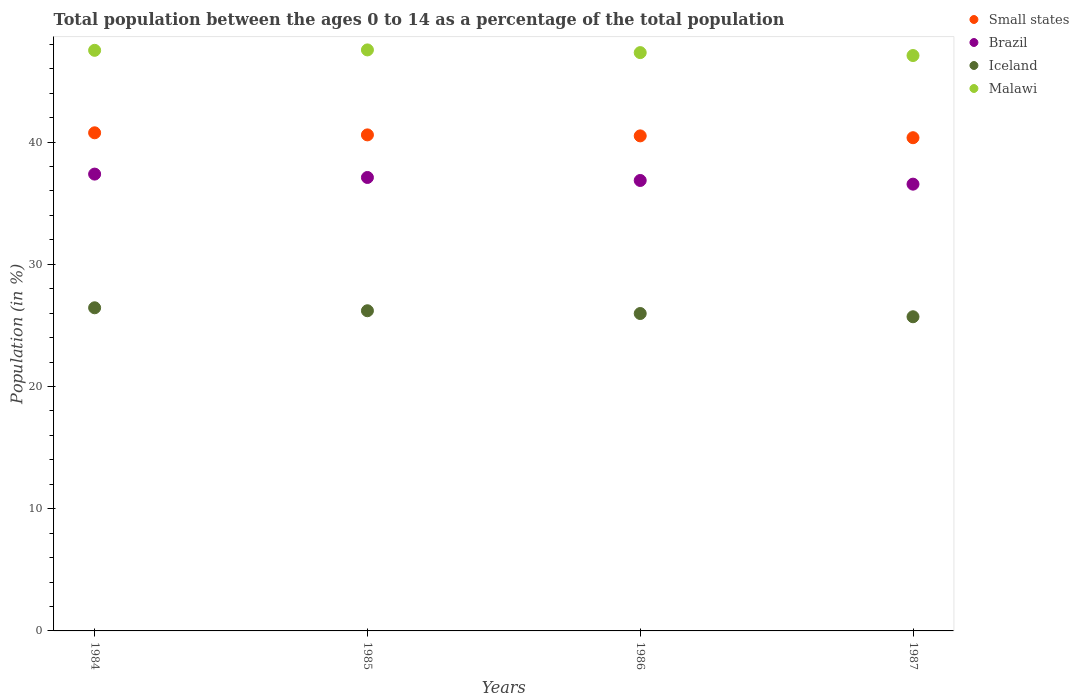How many different coloured dotlines are there?
Your answer should be very brief. 4. What is the percentage of the population ages 0 to 14 in Iceland in 1986?
Provide a short and direct response. 25.97. Across all years, what is the maximum percentage of the population ages 0 to 14 in Small states?
Provide a short and direct response. 40.75. Across all years, what is the minimum percentage of the population ages 0 to 14 in Iceland?
Ensure brevity in your answer.  25.7. In which year was the percentage of the population ages 0 to 14 in Iceland maximum?
Make the answer very short. 1984. What is the total percentage of the population ages 0 to 14 in Small states in the graph?
Give a very brief answer. 162.19. What is the difference between the percentage of the population ages 0 to 14 in Malawi in 1984 and that in 1986?
Your answer should be very brief. 0.19. What is the difference between the percentage of the population ages 0 to 14 in Brazil in 1985 and the percentage of the population ages 0 to 14 in Iceland in 1984?
Make the answer very short. 10.66. What is the average percentage of the population ages 0 to 14 in Small states per year?
Offer a very short reply. 40.55. In the year 1984, what is the difference between the percentage of the population ages 0 to 14 in Small states and percentage of the population ages 0 to 14 in Iceland?
Your response must be concise. 14.32. In how many years, is the percentage of the population ages 0 to 14 in Iceland greater than 44?
Make the answer very short. 0. What is the ratio of the percentage of the population ages 0 to 14 in Brazil in 1984 to that in 1985?
Ensure brevity in your answer.  1.01. Is the percentage of the population ages 0 to 14 in Small states in 1986 less than that in 1987?
Offer a very short reply. No. Is the difference between the percentage of the population ages 0 to 14 in Small states in 1984 and 1985 greater than the difference between the percentage of the population ages 0 to 14 in Iceland in 1984 and 1985?
Give a very brief answer. No. What is the difference between the highest and the second highest percentage of the population ages 0 to 14 in Malawi?
Provide a short and direct response. 0.03. What is the difference between the highest and the lowest percentage of the population ages 0 to 14 in Malawi?
Provide a short and direct response. 0.46. Is it the case that in every year, the sum of the percentage of the population ages 0 to 14 in Iceland and percentage of the population ages 0 to 14 in Brazil  is greater than the sum of percentage of the population ages 0 to 14 in Small states and percentage of the population ages 0 to 14 in Malawi?
Give a very brief answer. Yes. Is it the case that in every year, the sum of the percentage of the population ages 0 to 14 in Small states and percentage of the population ages 0 to 14 in Iceland  is greater than the percentage of the population ages 0 to 14 in Malawi?
Give a very brief answer. Yes. Is the percentage of the population ages 0 to 14 in Small states strictly greater than the percentage of the population ages 0 to 14 in Brazil over the years?
Give a very brief answer. Yes. How many years are there in the graph?
Your answer should be very brief. 4. Does the graph contain grids?
Give a very brief answer. No. Where does the legend appear in the graph?
Your response must be concise. Top right. How many legend labels are there?
Provide a succinct answer. 4. How are the legend labels stacked?
Offer a terse response. Vertical. What is the title of the graph?
Offer a very short reply. Total population between the ages 0 to 14 as a percentage of the total population. What is the label or title of the Y-axis?
Offer a very short reply. Population (in %). What is the Population (in %) in Small states in 1984?
Make the answer very short. 40.75. What is the Population (in %) in Brazil in 1984?
Provide a short and direct response. 37.37. What is the Population (in %) of Iceland in 1984?
Give a very brief answer. 26.44. What is the Population (in %) of Malawi in 1984?
Offer a very short reply. 47.5. What is the Population (in %) in Small states in 1985?
Make the answer very short. 40.58. What is the Population (in %) in Brazil in 1985?
Provide a succinct answer. 37.1. What is the Population (in %) of Iceland in 1985?
Ensure brevity in your answer.  26.19. What is the Population (in %) in Malawi in 1985?
Offer a terse response. 47.53. What is the Population (in %) in Small states in 1986?
Your answer should be very brief. 40.5. What is the Population (in %) in Brazil in 1986?
Make the answer very short. 36.85. What is the Population (in %) of Iceland in 1986?
Your answer should be very brief. 25.97. What is the Population (in %) in Malawi in 1986?
Your answer should be very brief. 47.31. What is the Population (in %) in Small states in 1987?
Offer a terse response. 40.35. What is the Population (in %) of Brazil in 1987?
Offer a terse response. 36.55. What is the Population (in %) of Iceland in 1987?
Provide a short and direct response. 25.7. What is the Population (in %) of Malawi in 1987?
Provide a short and direct response. 47.07. Across all years, what is the maximum Population (in %) in Small states?
Your response must be concise. 40.75. Across all years, what is the maximum Population (in %) in Brazil?
Keep it short and to the point. 37.37. Across all years, what is the maximum Population (in %) in Iceland?
Make the answer very short. 26.44. Across all years, what is the maximum Population (in %) of Malawi?
Offer a terse response. 47.53. Across all years, what is the minimum Population (in %) of Small states?
Your response must be concise. 40.35. Across all years, what is the minimum Population (in %) in Brazil?
Offer a terse response. 36.55. Across all years, what is the minimum Population (in %) in Iceland?
Provide a succinct answer. 25.7. Across all years, what is the minimum Population (in %) of Malawi?
Give a very brief answer. 47.07. What is the total Population (in %) in Small states in the graph?
Your response must be concise. 162.19. What is the total Population (in %) of Brazil in the graph?
Offer a terse response. 147.88. What is the total Population (in %) in Iceland in the graph?
Provide a short and direct response. 104.3. What is the total Population (in %) of Malawi in the graph?
Provide a short and direct response. 189.42. What is the difference between the Population (in %) in Small states in 1984 and that in 1985?
Provide a succinct answer. 0.17. What is the difference between the Population (in %) in Brazil in 1984 and that in 1985?
Offer a very short reply. 0.28. What is the difference between the Population (in %) in Iceland in 1984 and that in 1985?
Keep it short and to the point. 0.24. What is the difference between the Population (in %) of Malawi in 1984 and that in 1985?
Offer a terse response. -0.03. What is the difference between the Population (in %) of Small states in 1984 and that in 1986?
Your answer should be very brief. 0.25. What is the difference between the Population (in %) in Brazil in 1984 and that in 1986?
Your response must be concise. 0.52. What is the difference between the Population (in %) in Iceland in 1984 and that in 1986?
Your answer should be compact. 0.47. What is the difference between the Population (in %) in Malawi in 1984 and that in 1986?
Ensure brevity in your answer.  0.19. What is the difference between the Population (in %) of Small states in 1984 and that in 1987?
Keep it short and to the point. 0.4. What is the difference between the Population (in %) in Brazil in 1984 and that in 1987?
Ensure brevity in your answer.  0.82. What is the difference between the Population (in %) of Iceland in 1984 and that in 1987?
Ensure brevity in your answer.  0.73. What is the difference between the Population (in %) of Malawi in 1984 and that in 1987?
Your response must be concise. 0.43. What is the difference between the Population (in %) of Small states in 1985 and that in 1986?
Give a very brief answer. 0.08. What is the difference between the Population (in %) of Brazil in 1985 and that in 1986?
Make the answer very short. 0.25. What is the difference between the Population (in %) in Iceland in 1985 and that in 1986?
Offer a terse response. 0.23. What is the difference between the Population (in %) in Malawi in 1985 and that in 1986?
Ensure brevity in your answer.  0.22. What is the difference between the Population (in %) in Small states in 1985 and that in 1987?
Provide a short and direct response. 0.23. What is the difference between the Population (in %) in Brazil in 1985 and that in 1987?
Offer a terse response. 0.55. What is the difference between the Population (in %) of Iceland in 1985 and that in 1987?
Provide a short and direct response. 0.49. What is the difference between the Population (in %) of Malawi in 1985 and that in 1987?
Keep it short and to the point. 0.46. What is the difference between the Population (in %) in Small states in 1986 and that in 1987?
Offer a very short reply. 0.15. What is the difference between the Population (in %) of Brazil in 1986 and that in 1987?
Keep it short and to the point. 0.3. What is the difference between the Population (in %) of Iceland in 1986 and that in 1987?
Make the answer very short. 0.27. What is the difference between the Population (in %) of Malawi in 1986 and that in 1987?
Offer a very short reply. 0.24. What is the difference between the Population (in %) of Small states in 1984 and the Population (in %) of Brazil in 1985?
Offer a terse response. 3.65. What is the difference between the Population (in %) in Small states in 1984 and the Population (in %) in Iceland in 1985?
Make the answer very short. 14.56. What is the difference between the Population (in %) in Small states in 1984 and the Population (in %) in Malawi in 1985?
Your response must be concise. -6.78. What is the difference between the Population (in %) of Brazil in 1984 and the Population (in %) of Iceland in 1985?
Your response must be concise. 11.18. What is the difference between the Population (in %) in Brazil in 1984 and the Population (in %) in Malawi in 1985?
Keep it short and to the point. -10.16. What is the difference between the Population (in %) of Iceland in 1984 and the Population (in %) of Malawi in 1985?
Provide a short and direct response. -21.1. What is the difference between the Population (in %) in Small states in 1984 and the Population (in %) in Brazil in 1986?
Your answer should be very brief. 3.9. What is the difference between the Population (in %) in Small states in 1984 and the Population (in %) in Iceland in 1986?
Give a very brief answer. 14.79. What is the difference between the Population (in %) of Small states in 1984 and the Population (in %) of Malawi in 1986?
Give a very brief answer. -6.56. What is the difference between the Population (in %) in Brazil in 1984 and the Population (in %) in Iceland in 1986?
Keep it short and to the point. 11.41. What is the difference between the Population (in %) in Brazil in 1984 and the Population (in %) in Malawi in 1986?
Offer a terse response. -9.94. What is the difference between the Population (in %) of Iceland in 1984 and the Population (in %) of Malawi in 1986?
Provide a succinct answer. -20.88. What is the difference between the Population (in %) in Small states in 1984 and the Population (in %) in Brazil in 1987?
Your response must be concise. 4.2. What is the difference between the Population (in %) in Small states in 1984 and the Population (in %) in Iceland in 1987?
Provide a short and direct response. 15.05. What is the difference between the Population (in %) in Small states in 1984 and the Population (in %) in Malawi in 1987?
Give a very brief answer. -6.32. What is the difference between the Population (in %) of Brazil in 1984 and the Population (in %) of Iceland in 1987?
Provide a short and direct response. 11.67. What is the difference between the Population (in %) in Brazil in 1984 and the Population (in %) in Malawi in 1987?
Offer a terse response. -9.7. What is the difference between the Population (in %) in Iceland in 1984 and the Population (in %) in Malawi in 1987?
Your response must be concise. -20.64. What is the difference between the Population (in %) in Small states in 1985 and the Population (in %) in Brazil in 1986?
Provide a short and direct response. 3.73. What is the difference between the Population (in %) in Small states in 1985 and the Population (in %) in Iceland in 1986?
Make the answer very short. 14.61. What is the difference between the Population (in %) in Small states in 1985 and the Population (in %) in Malawi in 1986?
Provide a succinct answer. -6.73. What is the difference between the Population (in %) in Brazil in 1985 and the Population (in %) in Iceland in 1986?
Your answer should be compact. 11.13. What is the difference between the Population (in %) of Brazil in 1985 and the Population (in %) of Malawi in 1986?
Provide a succinct answer. -10.22. What is the difference between the Population (in %) in Iceland in 1985 and the Population (in %) in Malawi in 1986?
Keep it short and to the point. -21.12. What is the difference between the Population (in %) of Small states in 1985 and the Population (in %) of Brazil in 1987?
Provide a short and direct response. 4.03. What is the difference between the Population (in %) of Small states in 1985 and the Population (in %) of Iceland in 1987?
Your answer should be very brief. 14.88. What is the difference between the Population (in %) in Small states in 1985 and the Population (in %) in Malawi in 1987?
Provide a succinct answer. -6.49. What is the difference between the Population (in %) of Brazil in 1985 and the Population (in %) of Iceland in 1987?
Give a very brief answer. 11.4. What is the difference between the Population (in %) in Brazil in 1985 and the Population (in %) in Malawi in 1987?
Keep it short and to the point. -9.98. What is the difference between the Population (in %) in Iceland in 1985 and the Population (in %) in Malawi in 1987?
Offer a terse response. -20.88. What is the difference between the Population (in %) in Small states in 1986 and the Population (in %) in Brazil in 1987?
Provide a succinct answer. 3.95. What is the difference between the Population (in %) of Small states in 1986 and the Population (in %) of Iceland in 1987?
Your answer should be compact. 14.8. What is the difference between the Population (in %) of Small states in 1986 and the Population (in %) of Malawi in 1987?
Give a very brief answer. -6.57. What is the difference between the Population (in %) in Brazil in 1986 and the Population (in %) in Iceland in 1987?
Ensure brevity in your answer.  11.15. What is the difference between the Population (in %) of Brazil in 1986 and the Population (in %) of Malawi in 1987?
Your answer should be compact. -10.22. What is the difference between the Population (in %) in Iceland in 1986 and the Population (in %) in Malawi in 1987?
Give a very brief answer. -21.11. What is the average Population (in %) of Small states per year?
Provide a succinct answer. 40.55. What is the average Population (in %) in Brazil per year?
Make the answer very short. 36.97. What is the average Population (in %) in Iceland per year?
Give a very brief answer. 26.08. What is the average Population (in %) in Malawi per year?
Provide a succinct answer. 47.36. In the year 1984, what is the difference between the Population (in %) in Small states and Population (in %) in Brazil?
Your answer should be compact. 3.38. In the year 1984, what is the difference between the Population (in %) in Small states and Population (in %) in Iceland?
Your answer should be compact. 14.32. In the year 1984, what is the difference between the Population (in %) of Small states and Population (in %) of Malawi?
Your answer should be very brief. -6.75. In the year 1984, what is the difference between the Population (in %) of Brazil and Population (in %) of Iceland?
Provide a short and direct response. 10.94. In the year 1984, what is the difference between the Population (in %) in Brazil and Population (in %) in Malawi?
Your answer should be very brief. -10.13. In the year 1984, what is the difference between the Population (in %) in Iceland and Population (in %) in Malawi?
Ensure brevity in your answer.  -21.06. In the year 1985, what is the difference between the Population (in %) in Small states and Population (in %) in Brazil?
Offer a terse response. 3.48. In the year 1985, what is the difference between the Population (in %) in Small states and Population (in %) in Iceland?
Offer a terse response. 14.39. In the year 1985, what is the difference between the Population (in %) of Small states and Population (in %) of Malawi?
Give a very brief answer. -6.95. In the year 1985, what is the difference between the Population (in %) in Brazil and Population (in %) in Iceland?
Keep it short and to the point. 10.9. In the year 1985, what is the difference between the Population (in %) of Brazil and Population (in %) of Malawi?
Your response must be concise. -10.44. In the year 1985, what is the difference between the Population (in %) of Iceland and Population (in %) of Malawi?
Offer a terse response. -21.34. In the year 1986, what is the difference between the Population (in %) in Small states and Population (in %) in Brazil?
Your response must be concise. 3.65. In the year 1986, what is the difference between the Population (in %) in Small states and Population (in %) in Iceland?
Offer a terse response. 14.53. In the year 1986, what is the difference between the Population (in %) in Small states and Population (in %) in Malawi?
Provide a short and direct response. -6.81. In the year 1986, what is the difference between the Population (in %) of Brazil and Population (in %) of Iceland?
Your response must be concise. 10.88. In the year 1986, what is the difference between the Population (in %) in Brazil and Population (in %) in Malawi?
Keep it short and to the point. -10.46. In the year 1986, what is the difference between the Population (in %) of Iceland and Population (in %) of Malawi?
Your answer should be compact. -21.35. In the year 1987, what is the difference between the Population (in %) in Small states and Population (in %) in Brazil?
Provide a short and direct response. 3.8. In the year 1987, what is the difference between the Population (in %) of Small states and Population (in %) of Iceland?
Keep it short and to the point. 14.65. In the year 1987, what is the difference between the Population (in %) in Small states and Population (in %) in Malawi?
Provide a succinct answer. -6.72. In the year 1987, what is the difference between the Population (in %) of Brazil and Population (in %) of Iceland?
Provide a succinct answer. 10.85. In the year 1987, what is the difference between the Population (in %) of Brazil and Population (in %) of Malawi?
Make the answer very short. -10.52. In the year 1987, what is the difference between the Population (in %) of Iceland and Population (in %) of Malawi?
Your answer should be compact. -21.37. What is the ratio of the Population (in %) of Brazil in 1984 to that in 1985?
Offer a very short reply. 1.01. What is the ratio of the Population (in %) in Iceland in 1984 to that in 1985?
Offer a terse response. 1.01. What is the ratio of the Population (in %) of Malawi in 1984 to that in 1985?
Make the answer very short. 1. What is the ratio of the Population (in %) in Brazil in 1984 to that in 1986?
Keep it short and to the point. 1.01. What is the ratio of the Population (in %) in Iceland in 1984 to that in 1986?
Keep it short and to the point. 1.02. What is the ratio of the Population (in %) of Malawi in 1984 to that in 1986?
Provide a succinct answer. 1. What is the ratio of the Population (in %) in Brazil in 1984 to that in 1987?
Provide a short and direct response. 1.02. What is the ratio of the Population (in %) of Iceland in 1984 to that in 1987?
Your answer should be compact. 1.03. What is the ratio of the Population (in %) in Malawi in 1984 to that in 1987?
Offer a very short reply. 1.01. What is the ratio of the Population (in %) of Small states in 1985 to that in 1986?
Offer a very short reply. 1. What is the ratio of the Population (in %) of Brazil in 1985 to that in 1986?
Keep it short and to the point. 1.01. What is the ratio of the Population (in %) of Iceland in 1985 to that in 1986?
Your answer should be compact. 1.01. What is the ratio of the Population (in %) in Malawi in 1985 to that in 1986?
Provide a short and direct response. 1. What is the ratio of the Population (in %) in Small states in 1985 to that in 1987?
Keep it short and to the point. 1.01. What is the ratio of the Population (in %) of Brazil in 1985 to that in 1987?
Offer a very short reply. 1.01. What is the ratio of the Population (in %) in Iceland in 1985 to that in 1987?
Your answer should be very brief. 1.02. What is the ratio of the Population (in %) in Malawi in 1985 to that in 1987?
Provide a short and direct response. 1.01. What is the ratio of the Population (in %) of Brazil in 1986 to that in 1987?
Offer a very short reply. 1.01. What is the ratio of the Population (in %) in Iceland in 1986 to that in 1987?
Your response must be concise. 1.01. What is the difference between the highest and the second highest Population (in %) in Small states?
Your response must be concise. 0.17. What is the difference between the highest and the second highest Population (in %) in Brazil?
Your response must be concise. 0.28. What is the difference between the highest and the second highest Population (in %) in Iceland?
Provide a succinct answer. 0.24. What is the difference between the highest and the second highest Population (in %) of Malawi?
Your answer should be compact. 0.03. What is the difference between the highest and the lowest Population (in %) of Small states?
Provide a succinct answer. 0.4. What is the difference between the highest and the lowest Population (in %) in Brazil?
Ensure brevity in your answer.  0.82. What is the difference between the highest and the lowest Population (in %) of Iceland?
Offer a very short reply. 0.73. What is the difference between the highest and the lowest Population (in %) in Malawi?
Make the answer very short. 0.46. 